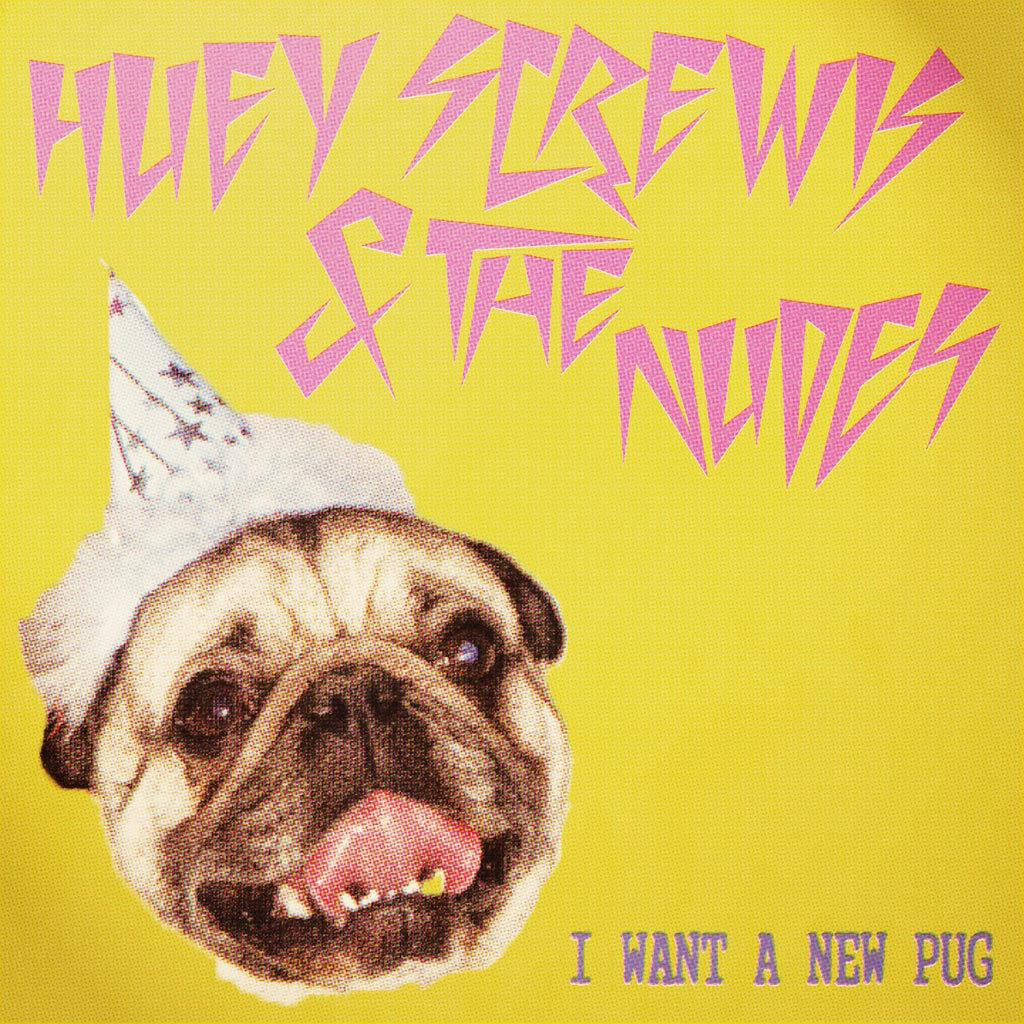What is the color of the poster in the image? The poster in the image is yellow. What can be found on the poster besides its color? The poster has some text on it. What other element is present in the image? There is a dog face in the image. How is the dog face dressed in the image? The dog face is wearing a birthday cap. Can you see any islands in the image? There are no islands present in the image. Is there a camera visible in the image? There is no camera visible in the image. 